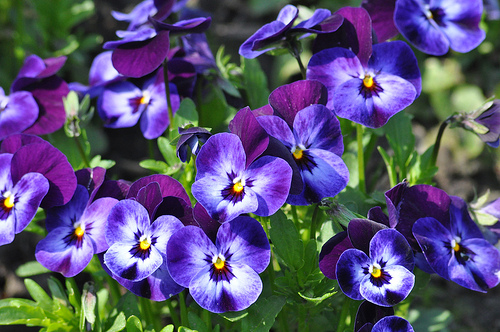<image>
Can you confirm if the flower is behind the leaves? No. The flower is not behind the leaves. From this viewpoint, the flower appears to be positioned elsewhere in the scene. 